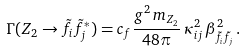<formula> <loc_0><loc_0><loc_500><loc_500>\Gamma ( Z _ { 2 } \rightarrow \tilde { f } _ { i } \tilde { f } _ { j } ^ { * } ) = c _ { f } \frac { g ^ { 2 } \, m _ { Z _ { 2 } } } { 4 8 \pi } \, \kappa _ { i j } ^ { 2 } \, \beta _ { \tilde { f } _ { i } \tilde { f } _ { j } } ^ { 2 } \, .</formula> 